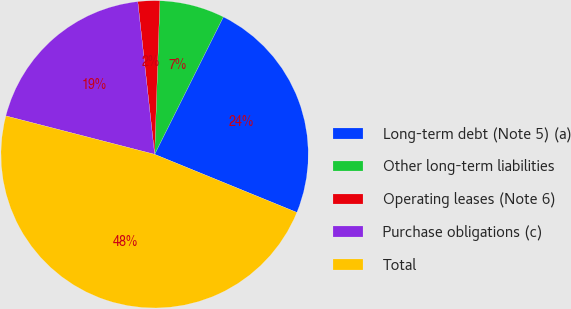<chart> <loc_0><loc_0><loc_500><loc_500><pie_chart><fcel>Long-term debt (Note 5) (a)<fcel>Other long-term liabilities<fcel>Operating leases (Note 6)<fcel>Purchase obligations (c)<fcel>Total<nl><fcel>23.79%<fcel>6.84%<fcel>2.29%<fcel>19.23%<fcel>47.85%<nl></chart> 